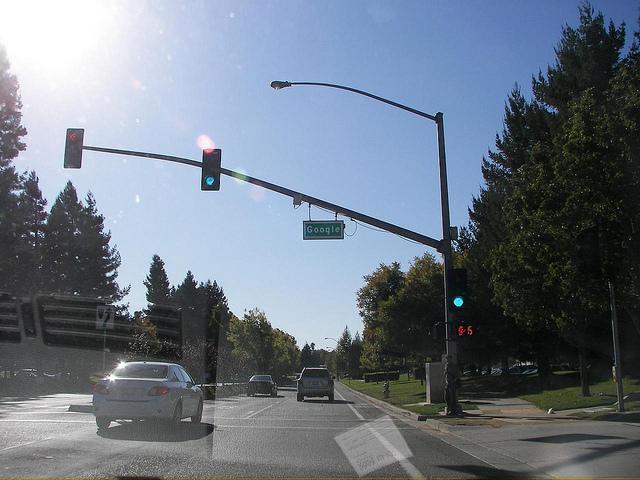What street is marked by the traffic light?
Select the accurate answer and provide justification: `Answer: choice
Rationale: srationale.`
Options: Google, apple, facebook, alphabet. Answer: google.
Rationale: Google's street is shown. 